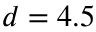Convert formula to latex. <formula><loc_0><loc_0><loc_500><loc_500>d = 4 . 5</formula> 